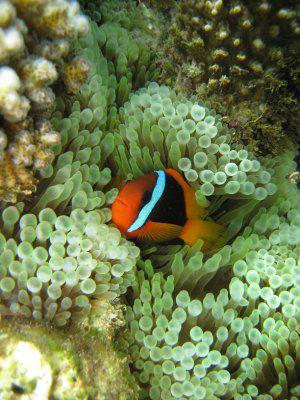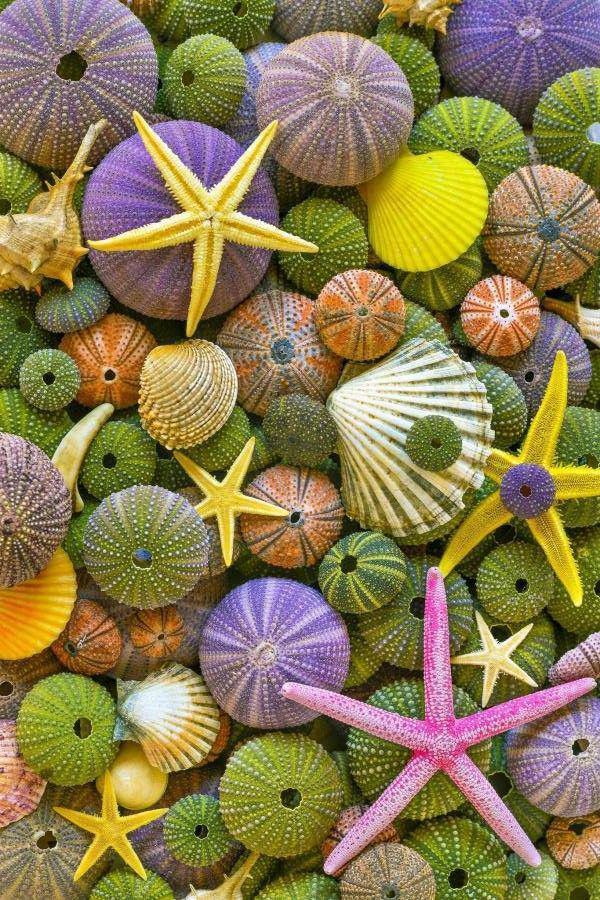The first image is the image on the left, the second image is the image on the right. Assess this claim about the two images: "A yellow, black and white striped fish is swimming around sea plants in the image on the left.". Correct or not? Answer yes or no. No. The first image is the image on the left, the second image is the image on the right. Examine the images to the left and right. Is the description "Each image includes a striped fish swimming near the tendrils of an anemone." accurate? Answer yes or no. No. 